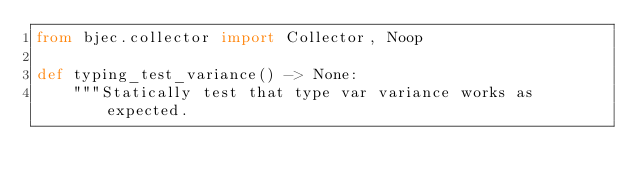<code> <loc_0><loc_0><loc_500><loc_500><_Python_>from bjec.collector import Collector, Noop

def typing_test_variance() -> None:
    """Statically test that type var variance works as expected.
</code> 